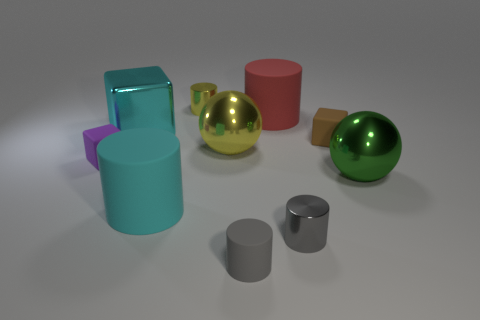Subtract 1 cylinders. How many cylinders are left? 4 Subtract all yellow cylinders. How many cylinders are left? 4 Subtract all cyan cylinders. How many cylinders are left? 4 Subtract all purple cylinders. Subtract all blue balls. How many cylinders are left? 5 Subtract all spheres. How many objects are left? 8 Subtract all gray balls. Subtract all cyan matte things. How many objects are left? 9 Add 6 small matte cylinders. How many small matte cylinders are left? 7 Add 9 purple rubber things. How many purple rubber things exist? 10 Subtract 0 purple balls. How many objects are left? 10 